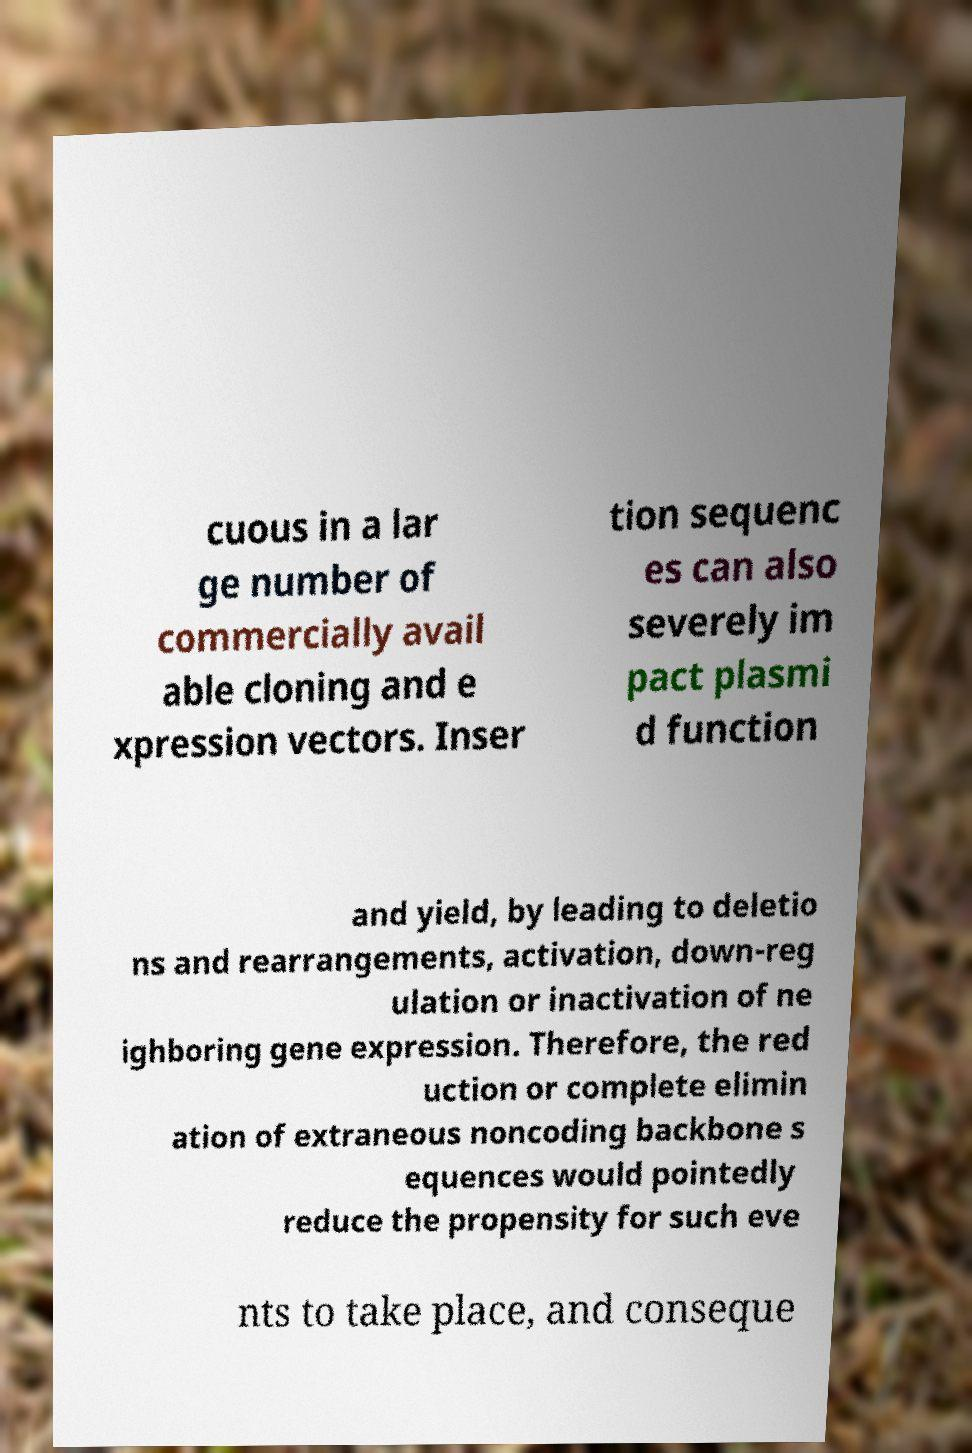Please read and relay the text visible in this image. What does it say? cuous in a lar ge number of commercially avail able cloning and e xpression vectors. Inser tion sequenc es can also severely im pact plasmi d function and yield, by leading to deletio ns and rearrangements, activation, down-reg ulation or inactivation of ne ighboring gene expression. Therefore, the red uction or complete elimin ation of extraneous noncoding backbone s equences would pointedly reduce the propensity for such eve nts to take place, and conseque 